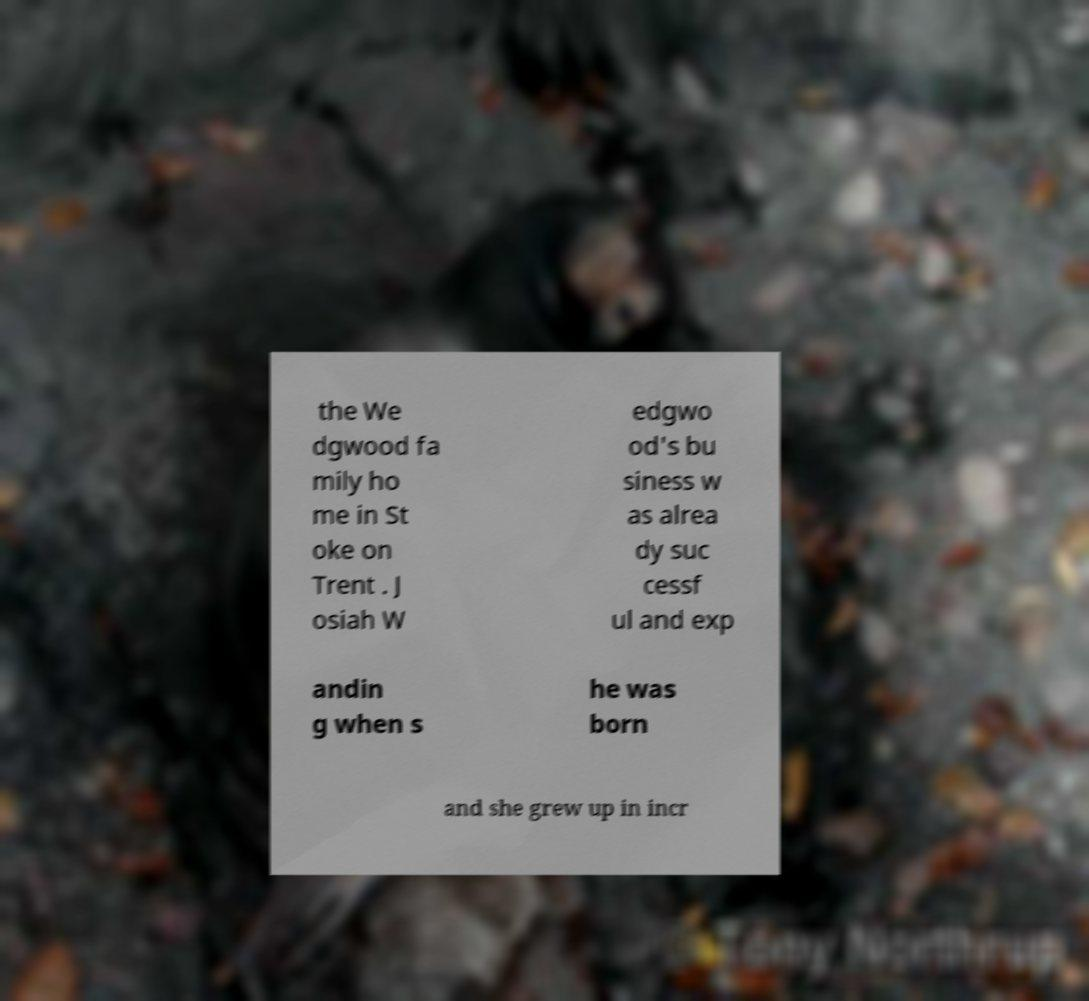Please read and relay the text visible in this image. What does it say? the We dgwood fa mily ho me in St oke on Trent . J osiah W edgwo od's bu siness w as alrea dy suc cessf ul and exp andin g when s he was born and she grew up in incr 